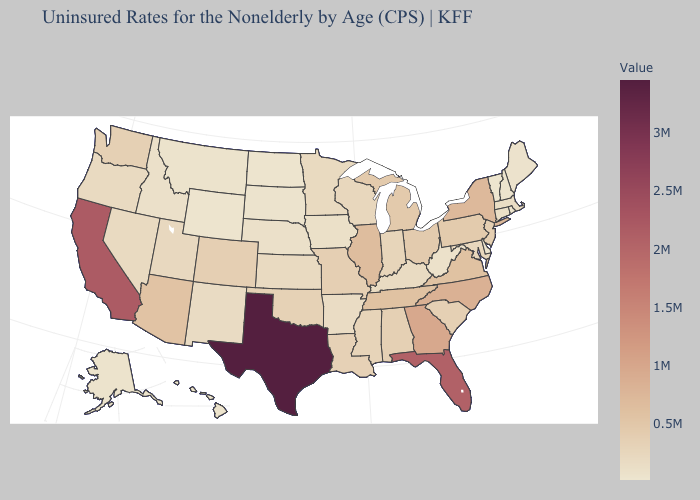Among the states that border Michigan , does Wisconsin have the highest value?
Quick response, please. No. Does Alabama have the highest value in the USA?
Keep it brief. No. Which states have the highest value in the USA?
Be succinct. Texas. 